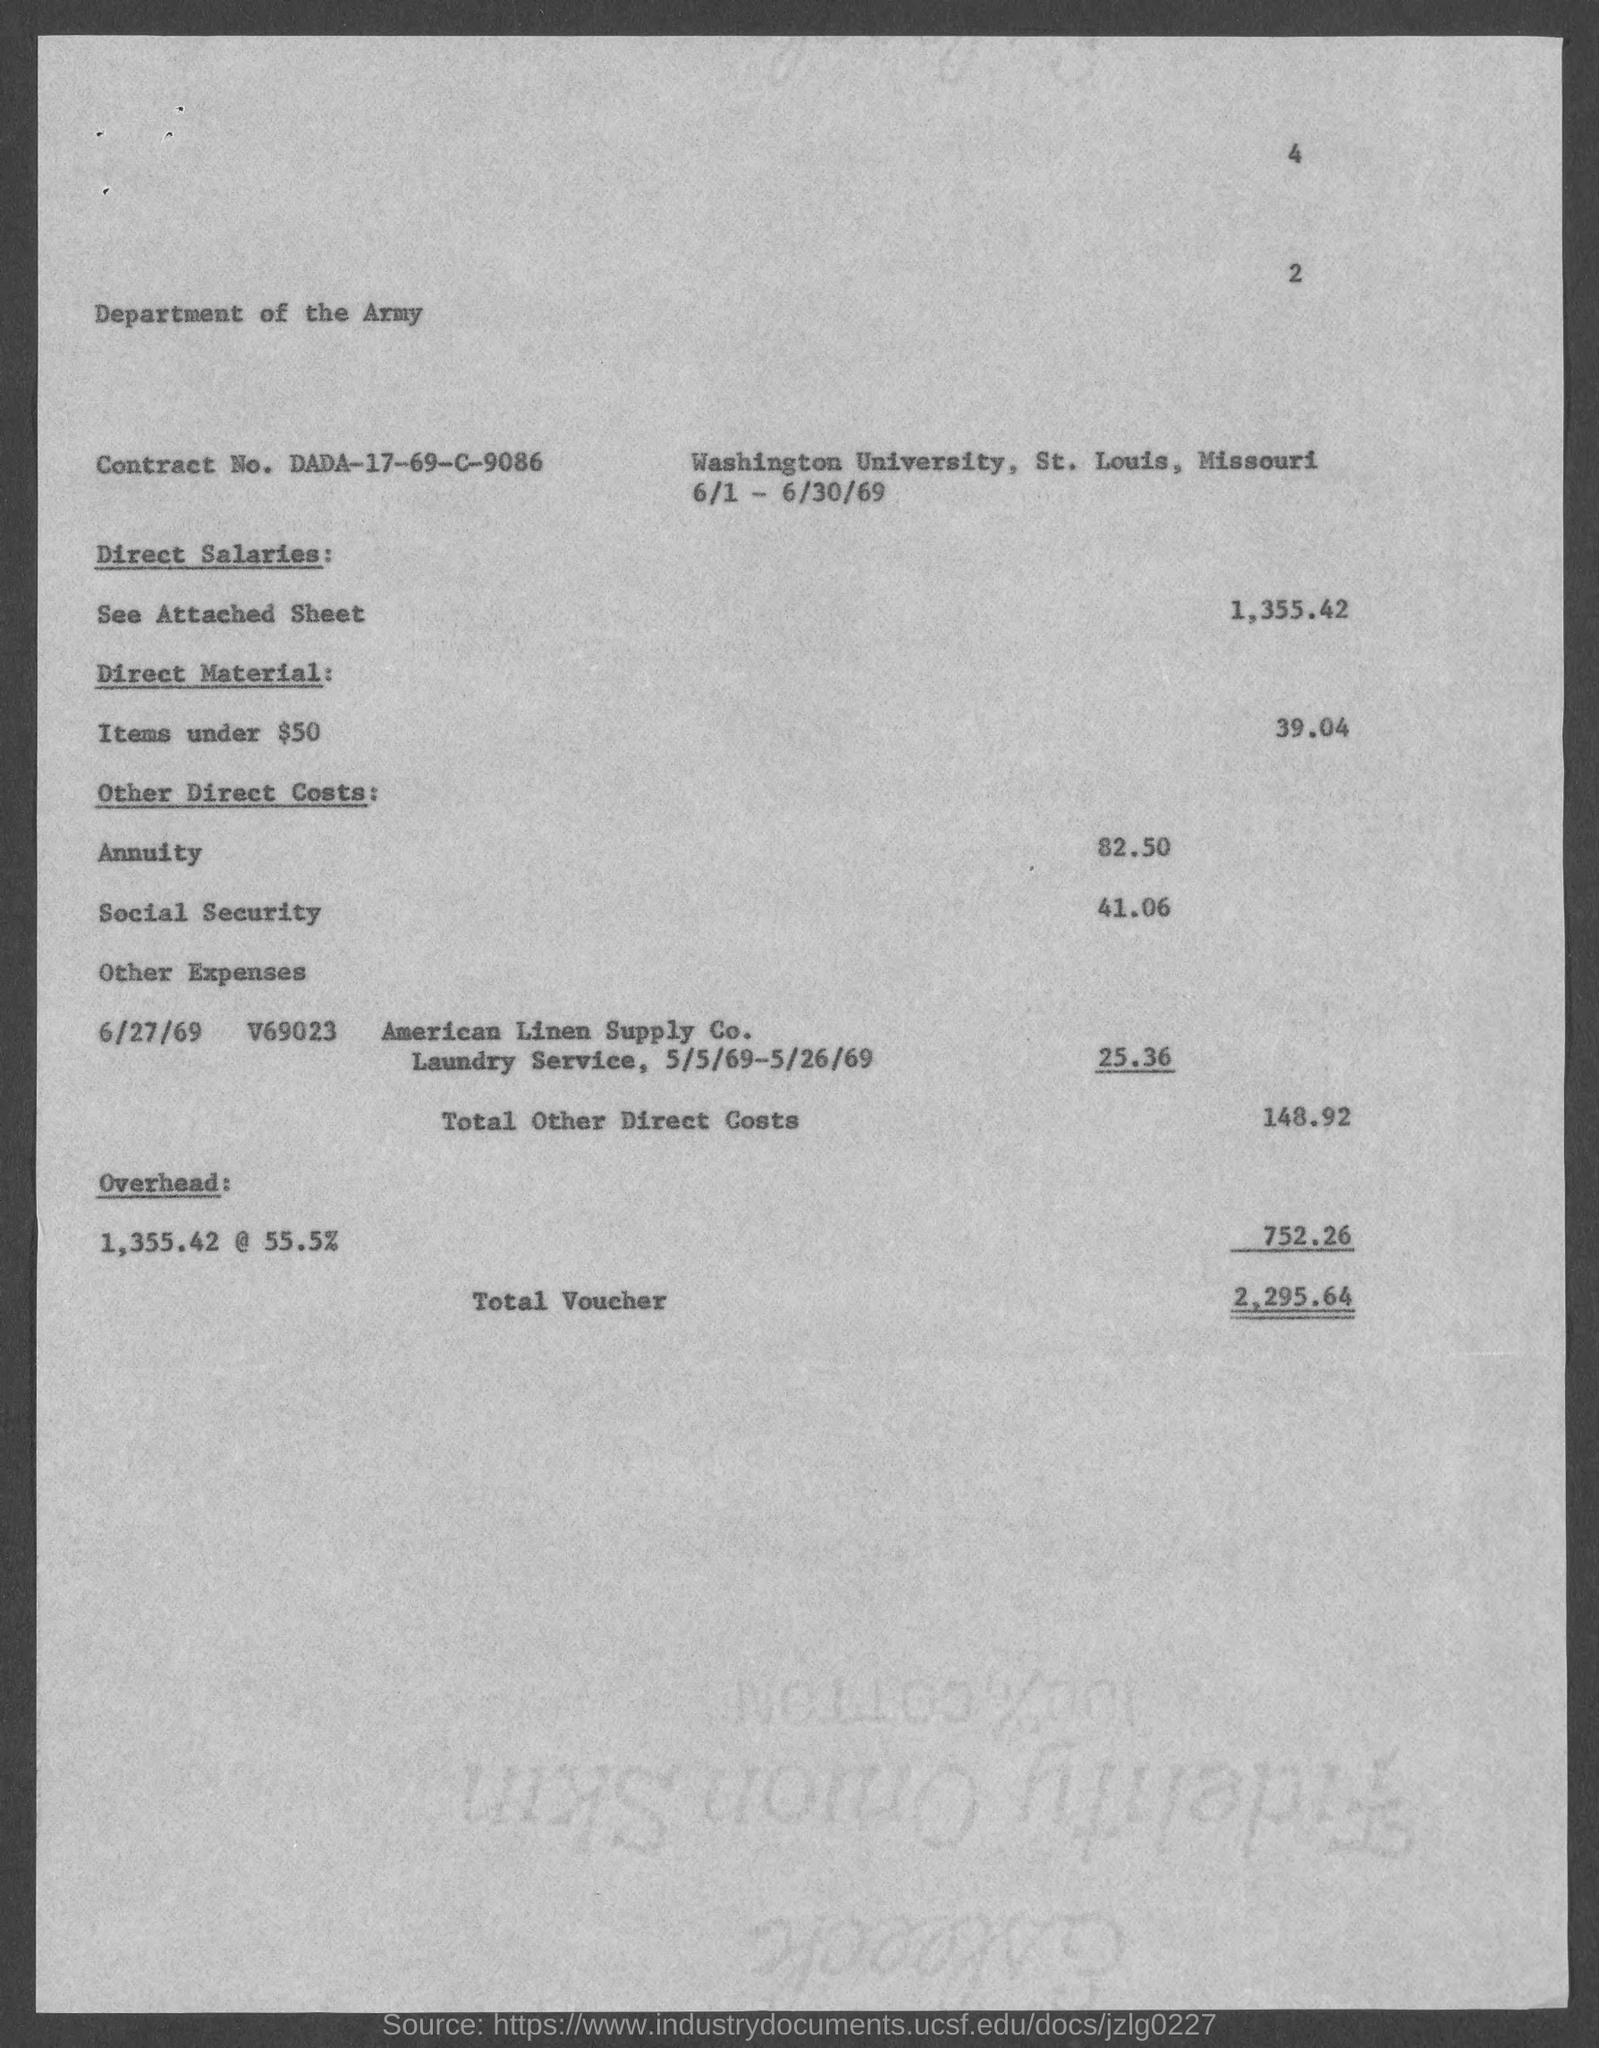What is the Contract No. given in the document?
Offer a terse response. DADA-17-69-C-9086. What is the annuity cost given in the document?
Offer a very short reply. 82.50. What is the social security cost mentioned in the document?
Offer a terse response. 41.06. What is the toal other direct costs given in the document?
Ensure brevity in your answer.  148.92. What is the total voucher amount mentioned in the document?
Ensure brevity in your answer.  2,295.64. What is the Direct material cost (Items under $50) given in the document?
Your answer should be very brief. 39.04. 